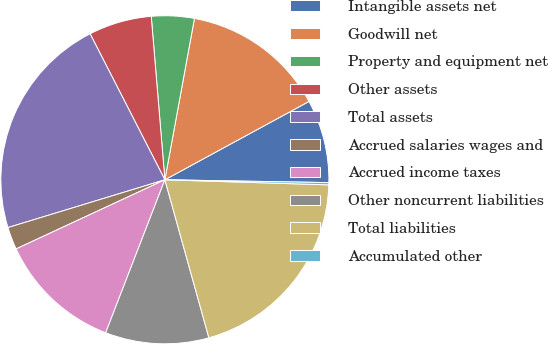Convert chart. <chart><loc_0><loc_0><loc_500><loc_500><pie_chart><fcel>Intangible assets net<fcel>Goodwill net<fcel>Property and equipment net<fcel>Other assets<fcel>Total assets<fcel>Accrued salaries wages and<fcel>Accrued income taxes<fcel>Other noncurrent liabilities<fcel>Total liabilities<fcel>Accumulated other<nl><fcel>8.2%<fcel>14.19%<fcel>4.21%<fcel>6.21%<fcel>22.17%<fcel>2.22%<fcel>12.2%<fcel>10.2%<fcel>20.18%<fcel>0.22%<nl></chart> 